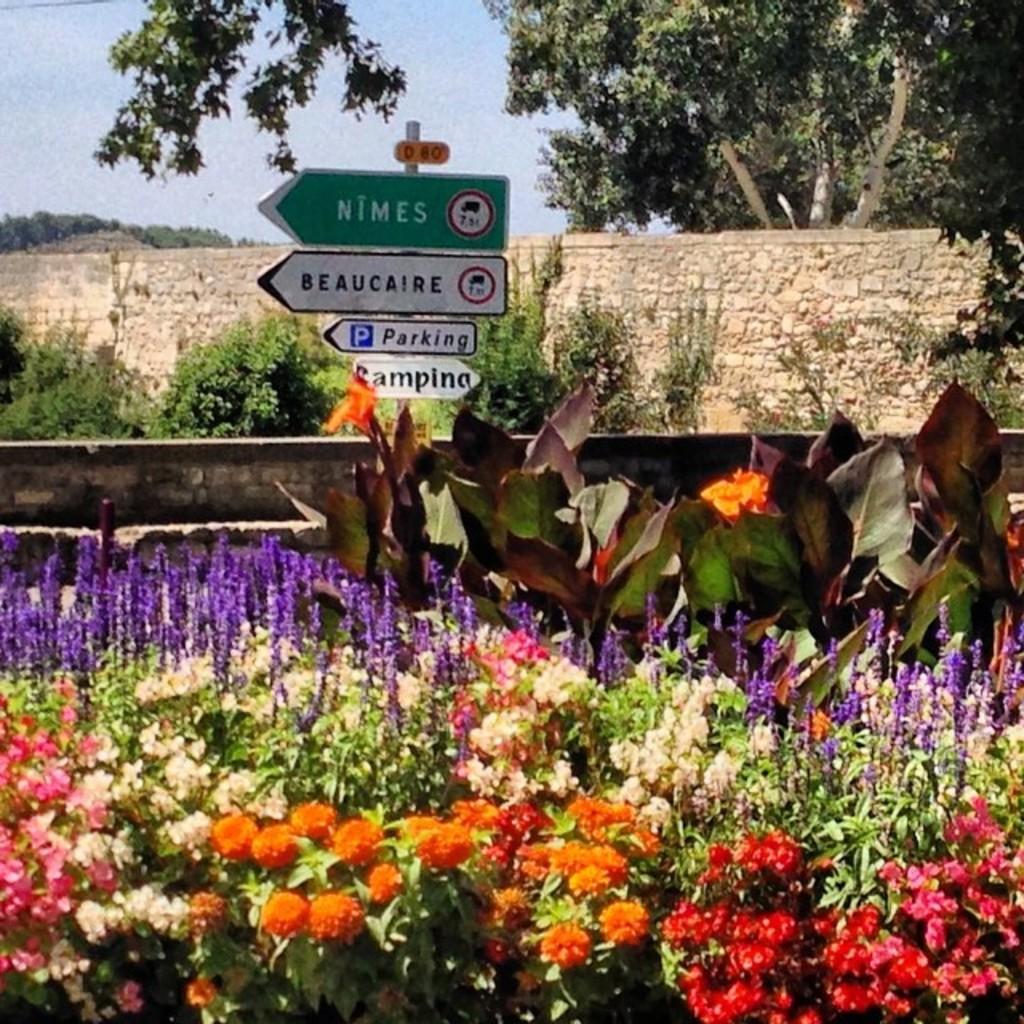In one or two sentences, can you explain what this image depicts? In this picture we can see flowers, plants, trees, walls, name boards attached to a pole and in the background we can see the sky. 